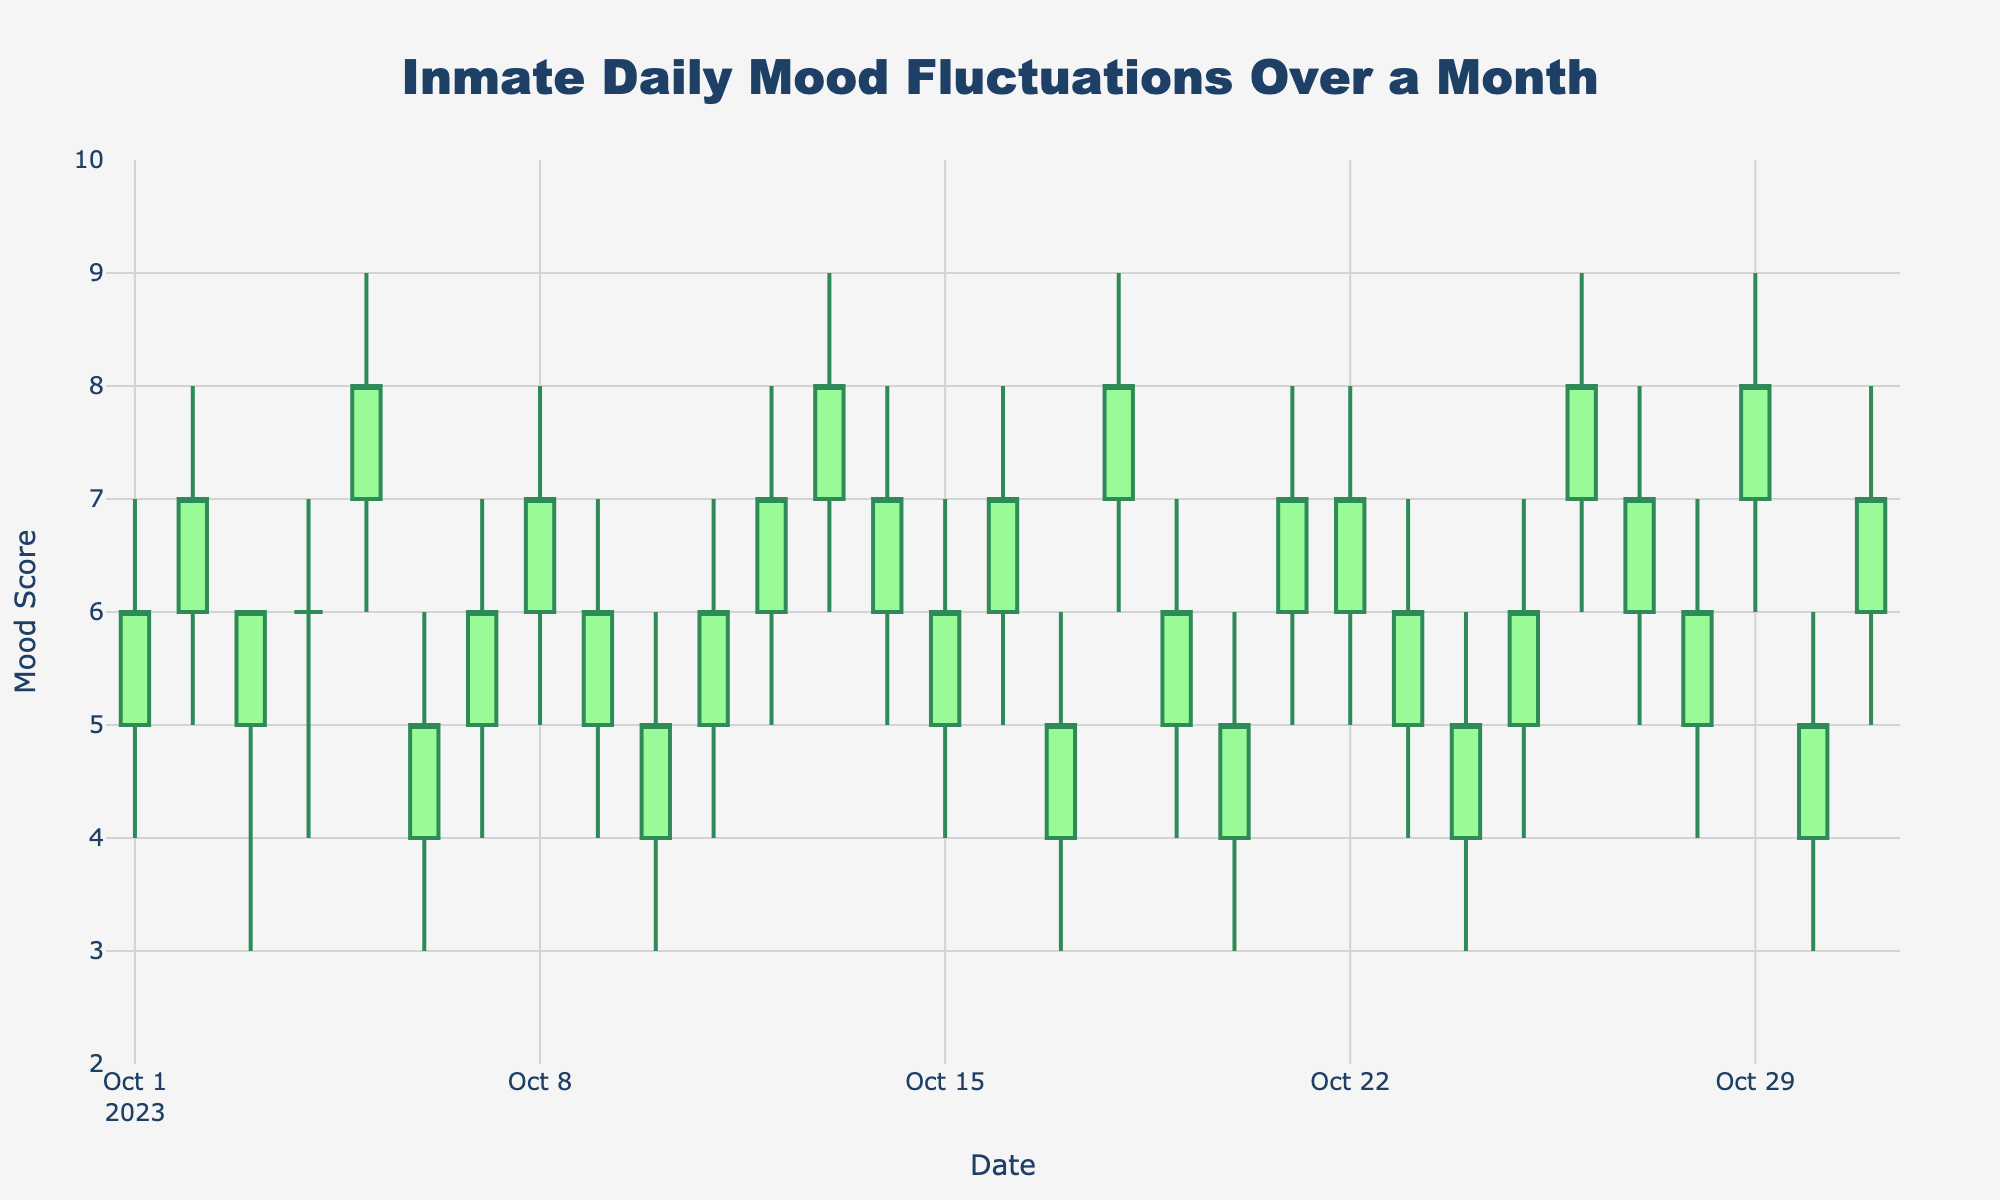What is the title of the figure? The title of the figure is prominently displayed at the top of the chart.
Answer: Inmate Daily Mood Fluctuations Over a Month What are the y-axis range values? The y-axis range values can be observed on the left side of the figure, and they range from 2 to 10.
Answer: 2 to 10 What does the green color on the candlestick represent? The green color on the candlestick indicates an increasing session, where the closing mood score is higher than the opening mood score.
Answer: Increasing session On which date did the highest mood score occur? By looking at the highest points on the chart, the highest mood score of 9 occurred on multiple dates such as October 5, 13, 18, 26, and 29.
Answer: October 5, 13, 18, 26, and 29 Which date shows the lowest closing mood score? The lowest closing mood score, which is 5, can be observed on several dates by looking at the closing values. It occurs on dates such as October 6, 10, 17, 20, 24, and 30.
Answer: October 6, 10, 17, 20, 24, and 30 How many days have an increasing mood score (green candles)? Counting the green candlesticks gives us the number of days with an increasing mood score: 16 days show an increasing session.
Answer: 16 days Which dates show a decreasing mood score (red candles) but with the same opening and closing values? By looking at the red candles and checking if the opening and closing values are the same, we find no such days as red candles represent different opening and closing values.
Answer: None Which date shows the greatest fluctuation in mood score? The greatest fluctuation in mood score can be determined by looking at the range between the high and low values. The widest range occurs on October 5 and 13, with a fluctuate of (9 - 6 = 3).
Answer: October 5 and 13 Compare the mood score trend from October 15 to October 20. From October 15 to 20, alternating mood score trends are observed where the scores increase one day and decrease the next.
Answer: Alternating trend What is the average high mood score over the month? To find the average high mood score, sum all the high values and divide by the number of days. The sum is (7 + 8 + 6 + 7 + 9 + 6 + 7 + 8 + 7 + 6 + 7 + 8 + 9 + 8 + 7 + 8 + 6 + 9 + 7 + 6 + 8 + 8 + 7 + 6 + 7 + 9 + 8 + 7 + 9 + 6 + 8) = 217, and there are 31 days. So, the average is 217/31 = 7.0
Answer: 7.0 